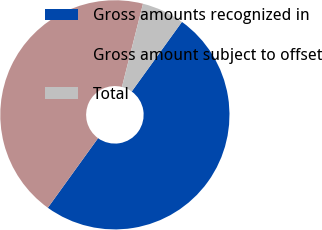<chart> <loc_0><loc_0><loc_500><loc_500><pie_chart><fcel>Gross amounts recognized in<fcel>Gross amount subject to offset<fcel>Total<nl><fcel>50.0%<fcel>44.0%<fcel>6.0%<nl></chart> 